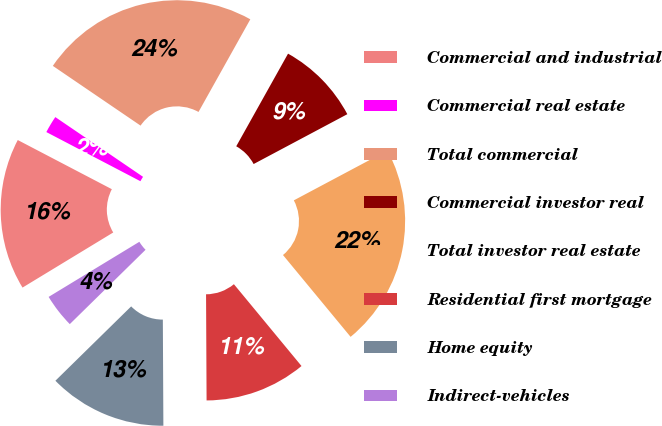<chart> <loc_0><loc_0><loc_500><loc_500><pie_chart><fcel>Commercial and industrial<fcel>Commercial real estate<fcel>Total commercial<fcel>Commercial investor real<fcel>Total investor real estate<fcel>Residential first mortgage<fcel>Home equity<fcel>Indirect-vehicles<nl><fcel>16.35%<fcel>1.85%<fcel>23.6%<fcel>9.1%<fcel>21.79%<fcel>10.91%<fcel>12.73%<fcel>3.66%<nl></chart> 